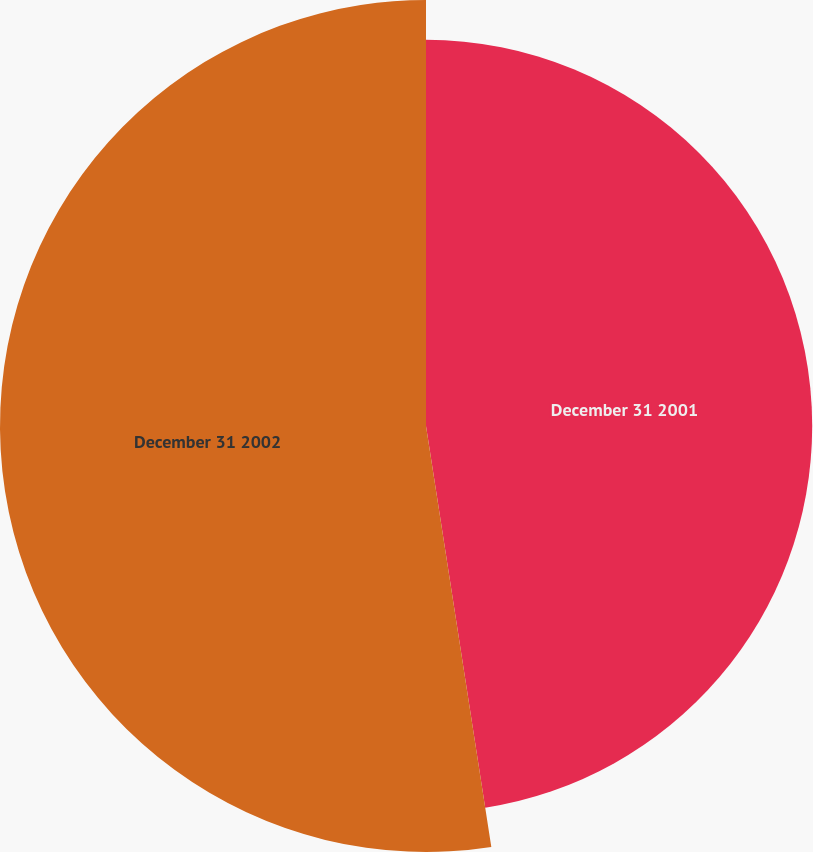Convert chart. <chart><loc_0><loc_0><loc_500><loc_500><pie_chart><fcel>December 31 2001<fcel>December 31 2002<nl><fcel>47.55%<fcel>52.45%<nl></chart> 